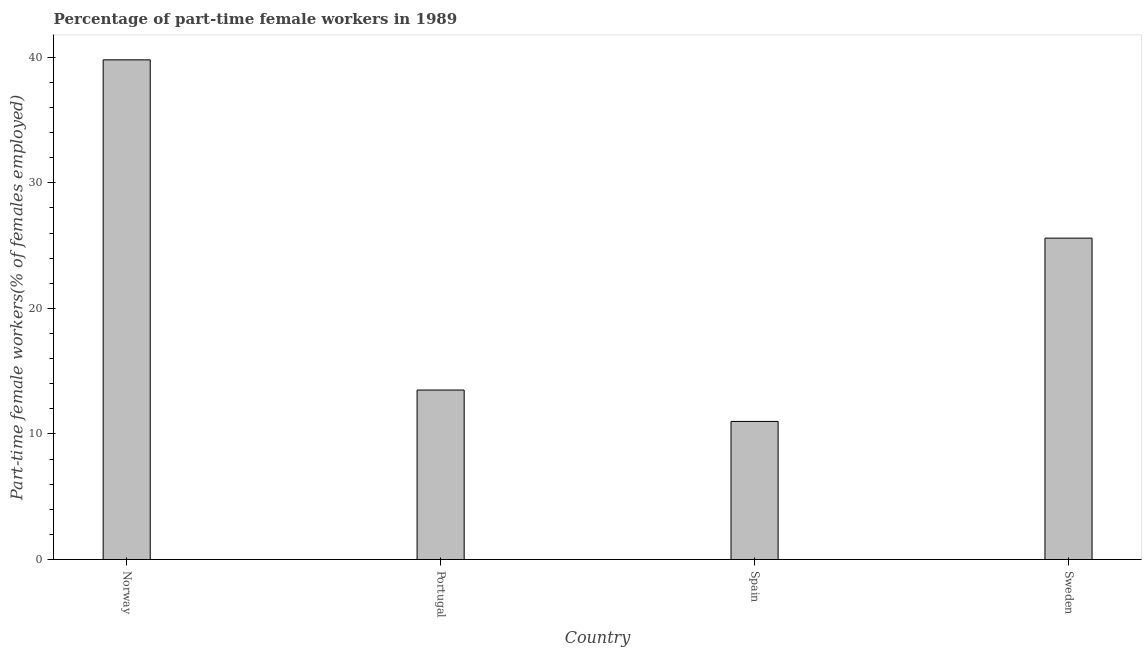Does the graph contain grids?
Offer a terse response. No. What is the title of the graph?
Keep it short and to the point. Percentage of part-time female workers in 1989. What is the label or title of the X-axis?
Keep it short and to the point. Country. What is the label or title of the Y-axis?
Provide a short and direct response. Part-time female workers(% of females employed). What is the percentage of part-time female workers in Norway?
Your answer should be very brief. 39.8. Across all countries, what is the maximum percentage of part-time female workers?
Offer a very short reply. 39.8. Across all countries, what is the minimum percentage of part-time female workers?
Provide a short and direct response. 11. In which country was the percentage of part-time female workers maximum?
Provide a succinct answer. Norway. What is the sum of the percentage of part-time female workers?
Ensure brevity in your answer.  89.9. What is the average percentage of part-time female workers per country?
Your response must be concise. 22.48. What is the median percentage of part-time female workers?
Provide a short and direct response. 19.55. In how many countries, is the percentage of part-time female workers greater than 24 %?
Offer a terse response. 2. What is the ratio of the percentage of part-time female workers in Portugal to that in Spain?
Offer a very short reply. 1.23. Is the difference between the percentage of part-time female workers in Norway and Spain greater than the difference between any two countries?
Your answer should be compact. Yes. What is the difference between the highest and the second highest percentage of part-time female workers?
Provide a succinct answer. 14.2. What is the difference between the highest and the lowest percentage of part-time female workers?
Your answer should be compact. 28.8. Are all the bars in the graph horizontal?
Your answer should be very brief. No. How many countries are there in the graph?
Provide a short and direct response. 4. What is the difference between two consecutive major ticks on the Y-axis?
Offer a very short reply. 10. What is the Part-time female workers(% of females employed) of Norway?
Your answer should be very brief. 39.8. What is the Part-time female workers(% of females employed) of Sweden?
Offer a very short reply. 25.6. What is the difference between the Part-time female workers(% of females employed) in Norway and Portugal?
Offer a very short reply. 26.3. What is the difference between the Part-time female workers(% of females employed) in Norway and Spain?
Your response must be concise. 28.8. What is the difference between the Part-time female workers(% of females employed) in Portugal and Spain?
Offer a very short reply. 2.5. What is the difference between the Part-time female workers(% of females employed) in Spain and Sweden?
Your answer should be compact. -14.6. What is the ratio of the Part-time female workers(% of females employed) in Norway to that in Portugal?
Give a very brief answer. 2.95. What is the ratio of the Part-time female workers(% of females employed) in Norway to that in Spain?
Give a very brief answer. 3.62. What is the ratio of the Part-time female workers(% of females employed) in Norway to that in Sweden?
Make the answer very short. 1.55. What is the ratio of the Part-time female workers(% of females employed) in Portugal to that in Spain?
Ensure brevity in your answer.  1.23. What is the ratio of the Part-time female workers(% of females employed) in Portugal to that in Sweden?
Keep it short and to the point. 0.53. What is the ratio of the Part-time female workers(% of females employed) in Spain to that in Sweden?
Offer a very short reply. 0.43. 